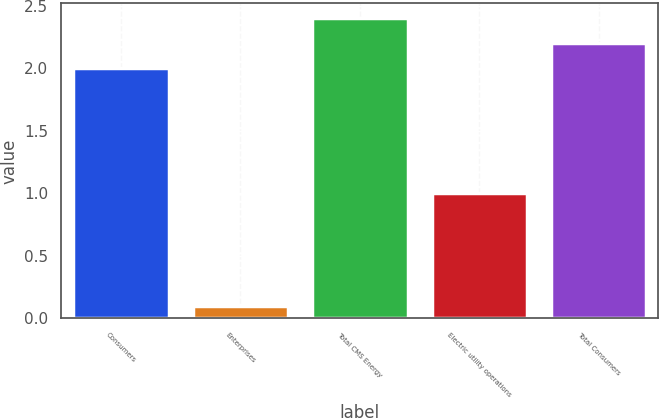<chart> <loc_0><loc_0><loc_500><loc_500><bar_chart><fcel>Consumers<fcel>Enterprises<fcel>Total CMS Energy<fcel>Electric utility operations<fcel>Total Consumers<nl><fcel>2<fcel>0.1<fcel>2.4<fcel>1<fcel>2.2<nl></chart> 